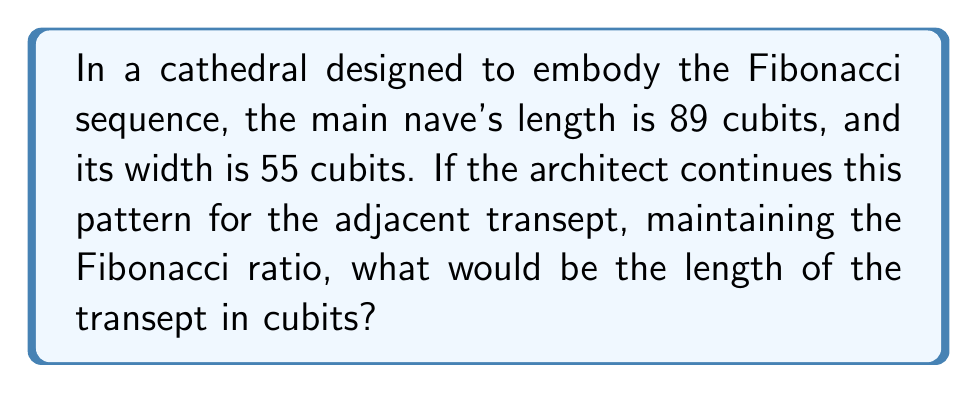Give your solution to this math problem. To solve this problem, we need to understand and apply the Fibonacci sequence and its properties:

1. The Fibonacci sequence: 0, 1, 1, 2, 3, 5, 8, 13, 21, 34, 55, 89, 144, ...

2. We observe that the nave's dimensions are Fibonacci numbers:
   Length = 89 cubits
   Width = 55 cubits

3. To maintain the Fibonacci ratio, we need to find the next number in the sequence after 89.

4. In the Fibonacci sequence, each number is the sum of the two preceding ones:
   $F_n = F_{n-1} + F_{n-2}$

5. Therefore, the next number after 89 would be:
   $89 + 55 = 144$

6. This means the transept's length should be 144 cubits to maintain the Fibonacci ratio with the nave's dimensions.

7. We can verify the ratio:
   $\frac{144}{89} \approx 1.6180$
   $\frac{89}{55} \approx 1.6182$

   These ratios are very close to the golden ratio ($\phi \approx 1.6180339887...$), which is a characteristic of the Fibonacci sequence.
Answer: 144 cubits 